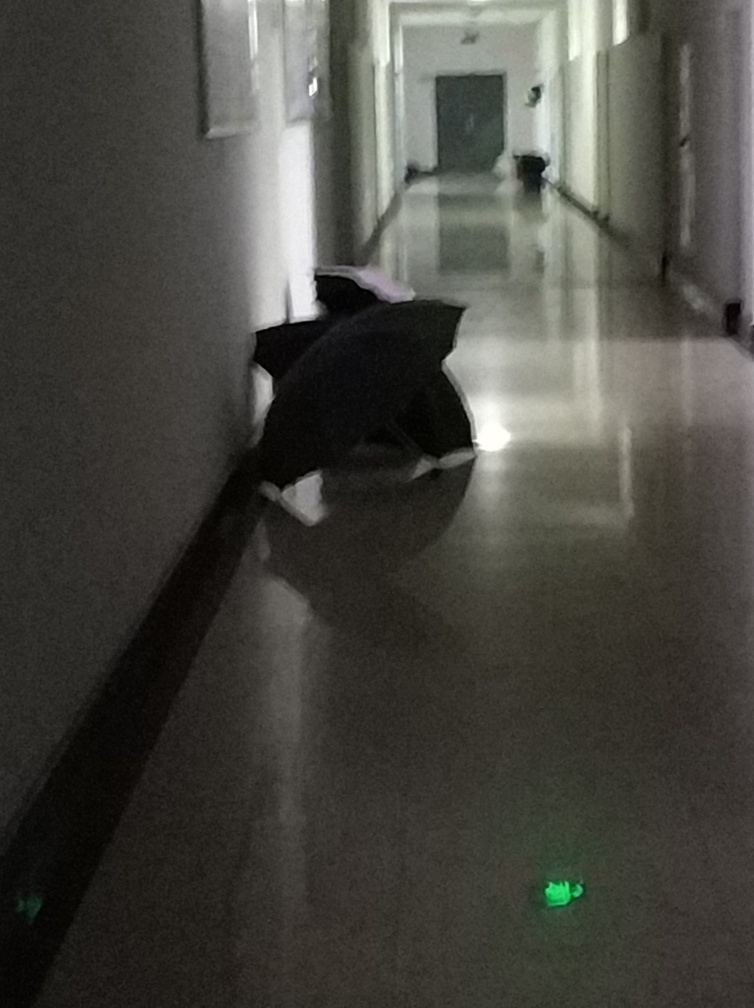Can you describe what is visible in this dimly lit image? The image shows a poorly illuminated indoor corridor, likely taken during evening hours or with limited artificial lighting. An open umbrella is resting on the floor, hinting at recent rain or its use as a makeshift prop. The walls and floor reflect a faint sheen, possibly from cleaning or the reflective nature of the material used. There's a soft glow coming from safety lights or electronic devices at the bottom of the walls, which provide minimal visibility. 